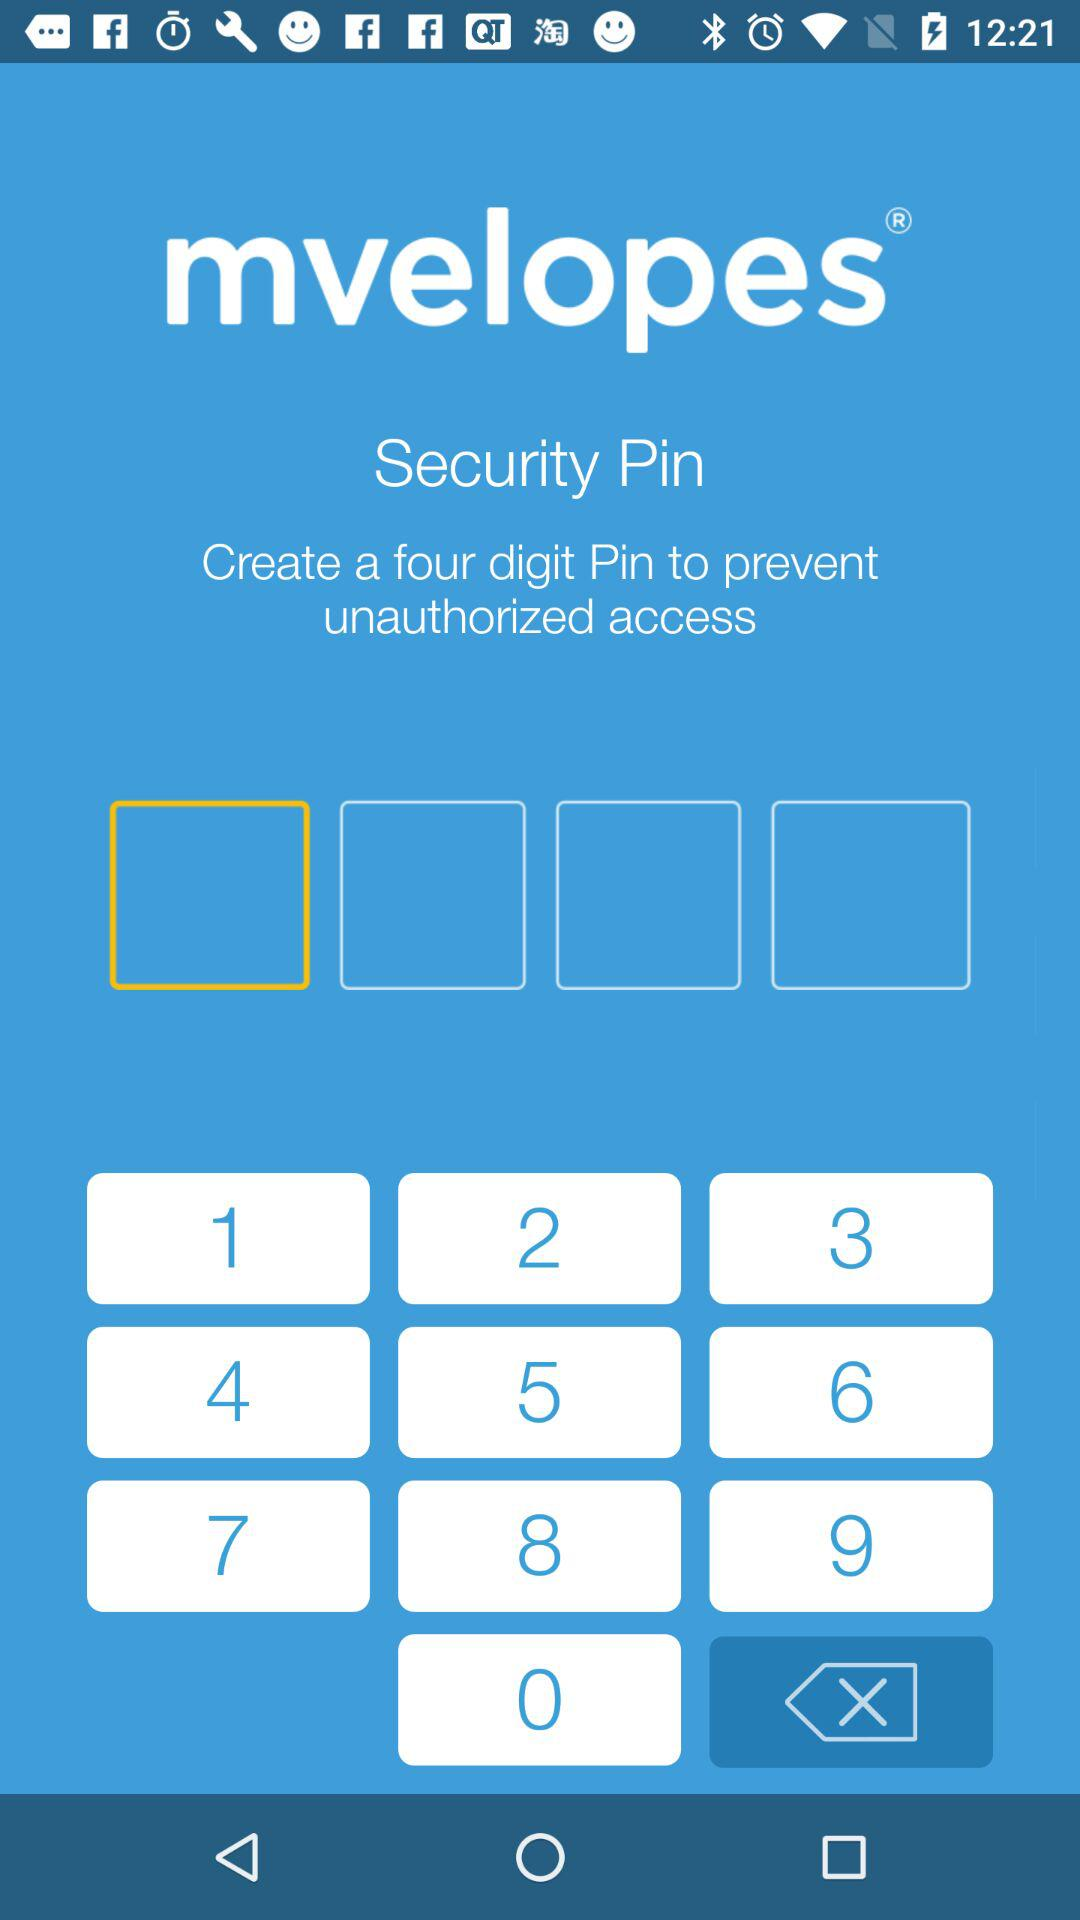What is the name of the application? The name of the application is "mvelopes". 